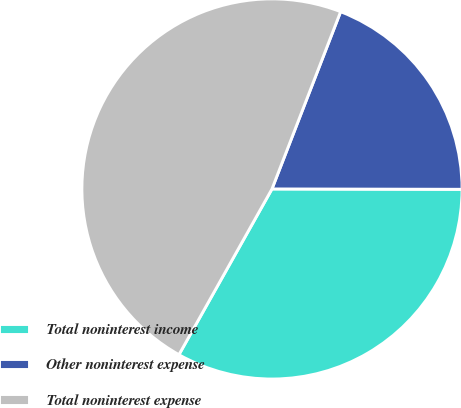Convert chart to OTSL. <chart><loc_0><loc_0><loc_500><loc_500><pie_chart><fcel>Total noninterest income<fcel>Other noninterest expense<fcel>Total noninterest expense<nl><fcel>33.11%<fcel>19.15%<fcel>47.74%<nl></chart> 